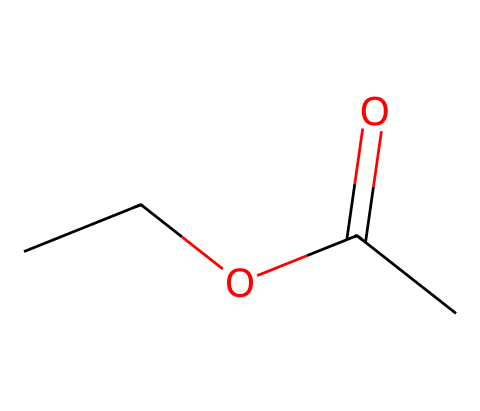What is the functional group present in ethyl acetate? The functional group in ethyl acetate is identified by the presence of a carbonyl group (C=O) bonded to an oxygen atom (–O), which is characteristic of esters.
Answer: ester How many carbon atoms are in ethyl acetate? The SMILES representation shows three carbon atoms directly involved in the backbone (two from the ethyl group and one from the carbonyl), indicating that there are a total of four carbon atoms in the structure.
Answer: four What type of bond connects the carbonyl carbon to the attached oxygen in ethyl acetate? The bond between the carbonyl carbon and the attached oxygen atom is specifically a double bond (C=O), as represented in the structure, which is typical for carbonyl groups found in esters.
Answer: double bond What is the total number of oxygen atoms in ethyl acetate? From the structure, there are two oxygen atoms present: one in the carbonyl group and another in the ether (-O-) part of the ester.
Answer: two Is ethyl acetate a solvent that is polar or nonpolar? Ethyl acetate has both polar and nonpolar characteristics due to its ester group, but it is generally classified as a nonpolar solvent because the hydrocarbon part dominates its solvent behavior, making it suitable for dissolving organic compounds.
Answer: nonpolar What is the molecular formula of ethyl acetate? By analyzing the SMILES representation, the number of each type of atom (2 carbon from ethyl + 1 carbon in carbonyl + 4 hydrogen + 2 oxygen) leads to the molecular formula C4H8O2.
Answer: C4H8O2 What makes ethyl acetate a common solvent in nail polish removers? Ethyl acetate has the ability to dissolve various organic materials effectively, which makes it suitable for breaking down nail polish, and its volatility allows for quick evaporation after application, making it an ideal solvent for nail polish removers.
Answer: effective solvent 